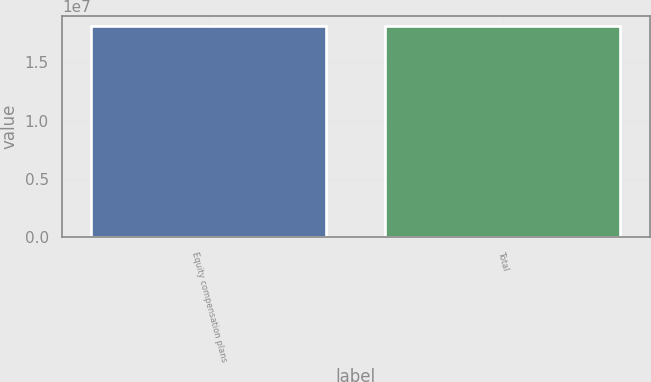<chart> <loc_0><loc_0><loc_500><loc_500><bar_chart><fcel>Equity compensation plans<fcel>Total<nl><fcel>1.80964e+07<fcel>1.80964e+07<nl></chart> 